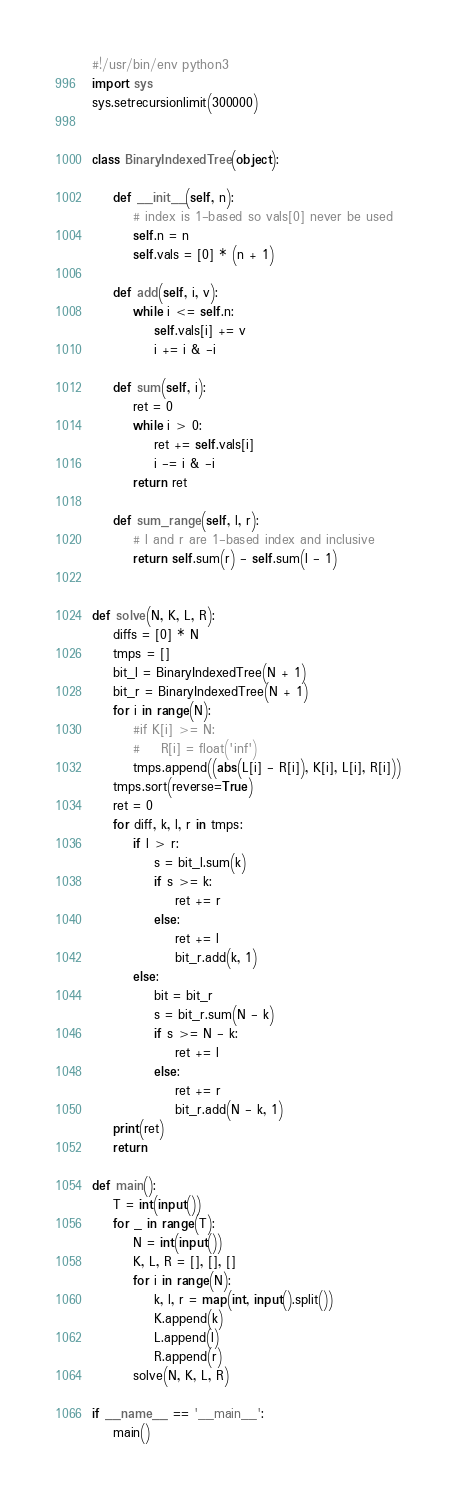Convert code to text. <code><loc_0><loc_0><loc_500><loc_500><_Python_>#!/usr/bin/env python3
import sys
sys.setrecursionlimit(300000)


class BinaryIndexedTree(object):

    def __init__(self, n):
        # index is 1-based so vals[0] never be used
        self.n = n
        self.vals = [0] * (n + 1)

    def add(self, i, v):
        while i <= self.n:
            self.vals[i] += v
            i += i & -i

    def sum(self, i):
        ret = 0
        while i > 0:
            ret += self.vals[i]
            i -= i & -i
        return ret

    def sum_range(self, l, r):
        # l and r are 1-based index and inclusive
        return self.sum(r) - self.sum(l - 1)


def solve(N, K, L, R):
    diffs = [0] * N
    tmps = []
    bit_l = BinaryIndexedTree(N + 1)
    bit_r = BinaryIndexedTree(N + 1)
    for i in range(N):
        #if K[i] >= N:
        #    R[i] = float('inf')
        tmps.append((abs(L[i] - R[i]), K[i], L[i], R[i]))
    tmps.sort(reverse=True)
    ret = 0
    for diff, k, l, r in tmps:
        if l > r:
            s = bit_l.sum(k)
            if s >= k:
                ret += r
            else:
                ret += l
                bit_r.add(k, 1)
        else:
            bit = bit_r
            s = bit_r.sum(N - k)
            if s >= N - k:
                ret += l
            else:
                ret += r
                bit_r.add(N - k, 1)
    print(ret)
    return

def main():
    T = int(input())
    for _ in range(T):
        N = int(input())
        K, L, R = [], [], []
        for i in range(N):
            k, l, r = map(int, input().split())
            K.append(k)
            L.append(l)
            R.append(r)
        solve(N, K, L, R)

if __name__ == '__main__':
    main()
</code> 